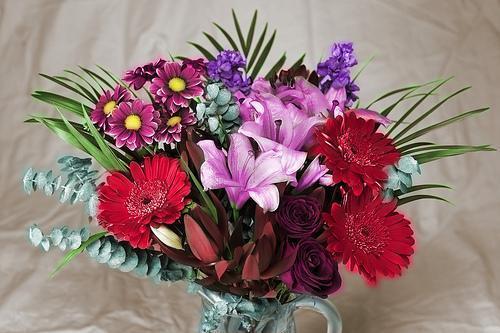How many vases are there?
Give a very brief answer. 1. 